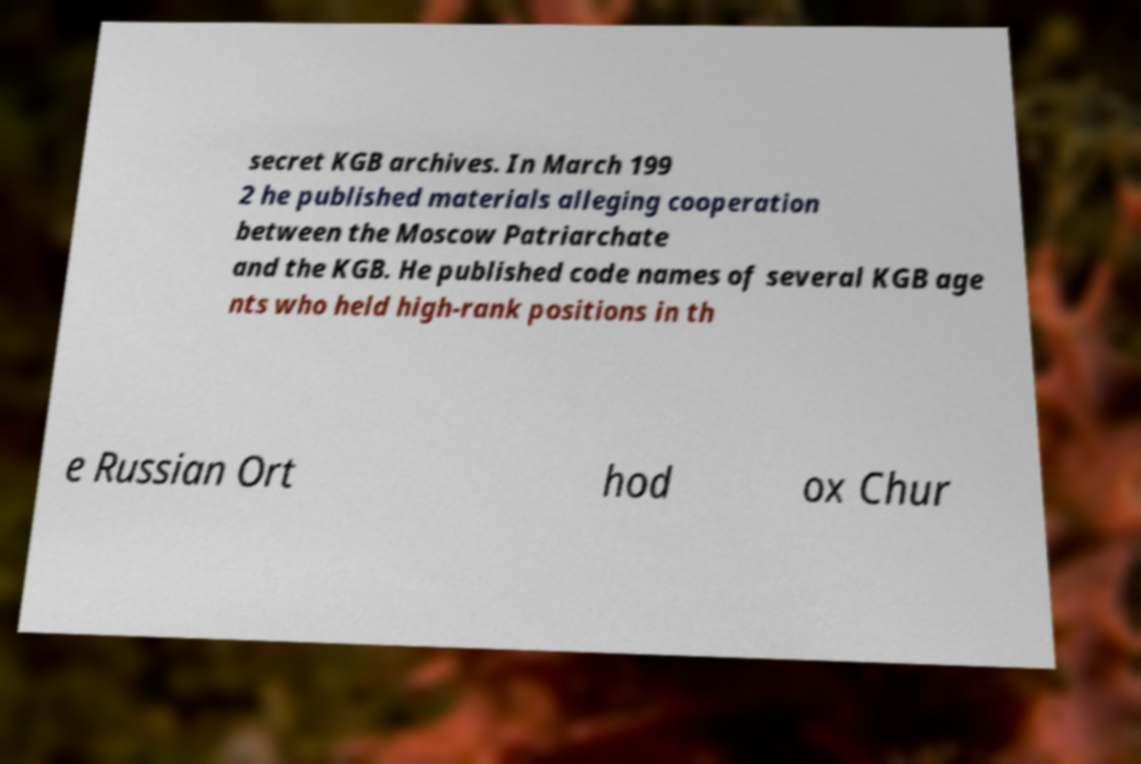Please read and relay the text visible in this image. What does it say? secret KGB archives. In March 199 2 he published materials alleging cooperation between the Moscow Patriarchate and the KGB. He published code names of several KGB age nts who held high-rank positions in th e Russian Ort hod ox Chur 